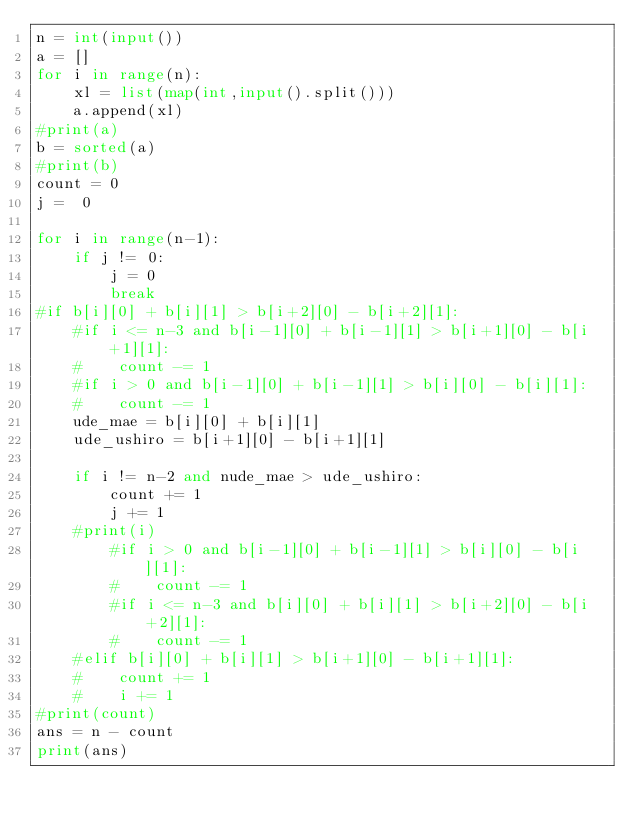Convert code to text. <code><loc_0><loc_0><loc_500><loc_500><_Python_>n = int(input())
a = []
for i in range(n):
    xl = list(map(int,input().split()))
    a.append(xl)
#print(a)
b = sorted(a)
#print(b)
count = 0
j =  0

for i in range(n-1):
    if j != 0:
        j = 0
        break
#if b[i][0] + b[i][1] > b[i+2][0] - b[i+2][1]:
    #if i <= n-3 and b[i-1][0] + b[i-1][1] > b[i+1][0] - b[i+1][1]:
    #    count -= 1
    #if i > 0 and b[i-1][0] + b[i-1][1] > b[i][0] - b[i][1]:
    #    count -= 1
    ude_mae = b[i][0] + b[i][1]
    ude_ushiro = b[i+1][0] - b[i+1][1]

    if i != n-2 and nude_mae > ude_ushiro:
        count += 1
        j += 1
    #print(i)
        #if i > 0 and b[i-1][0] + b[i-1][1] > b[i][0] - b[i][1]:
        #    count -= 1
        #if i <= n-3 and b[i][0] + b[i][1] > b[i+2][0] - b[i+2][1]:
        #    count -= 1
    #elif b[i][0] + b[i][1] > b[i+1][0] - b[i+1][1]:
    #    count += 1
    #    i += 1
#print(count)
ans = n - count
print(ans)</code> 